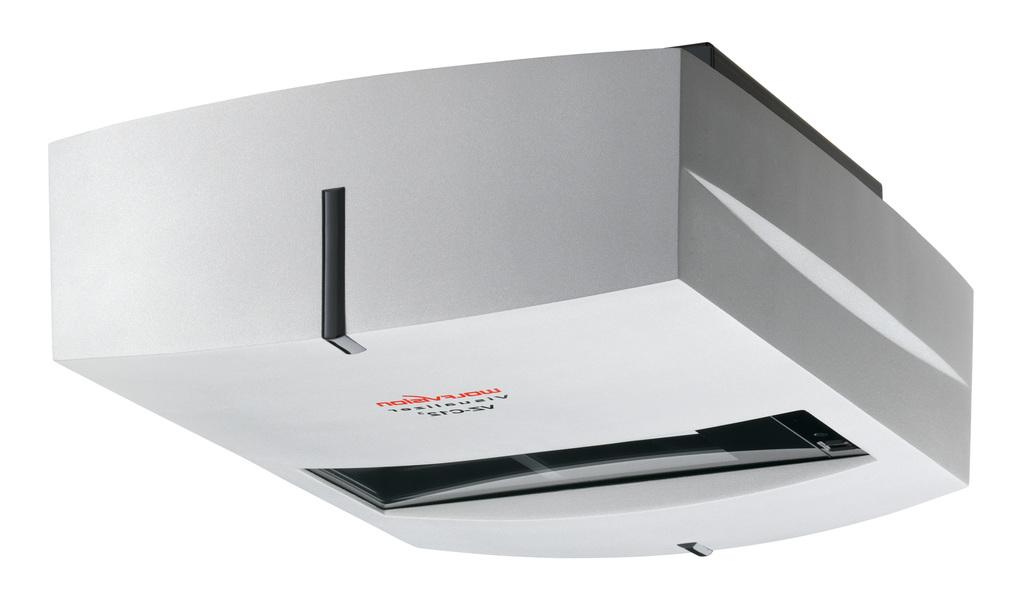What type of electronic device is visible in the image? The facts provided do not specify the type of electronic device in the image. What color is the background of the image? The background of the image is white. Can you see a stream flowing in the background of the image? There is no mention of a stream in the image; the background is white. What type of turkey is being used as part of the electronic device in the image? There is no turkey present in the image, and the electronic device is not specified. 